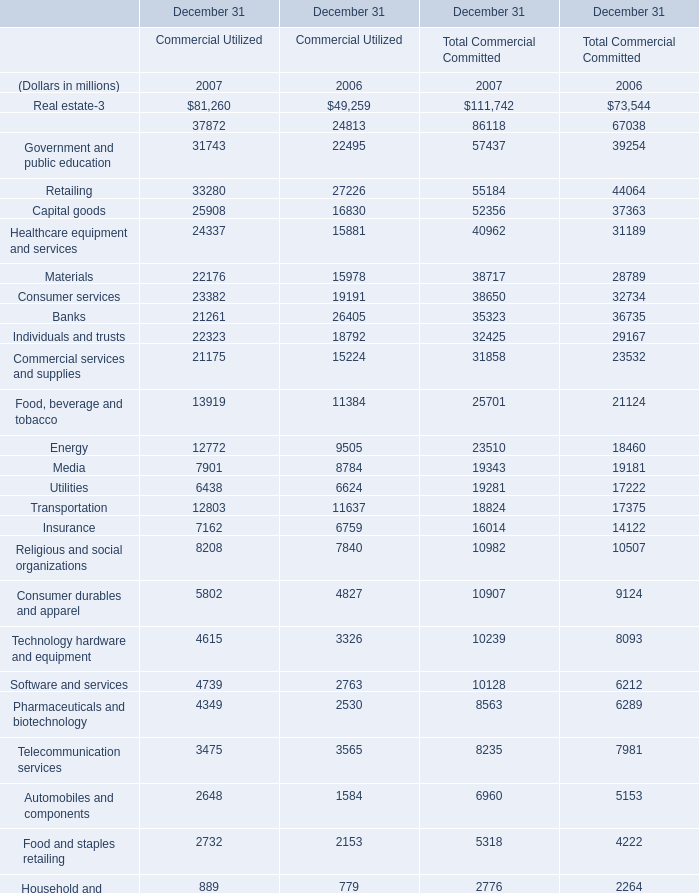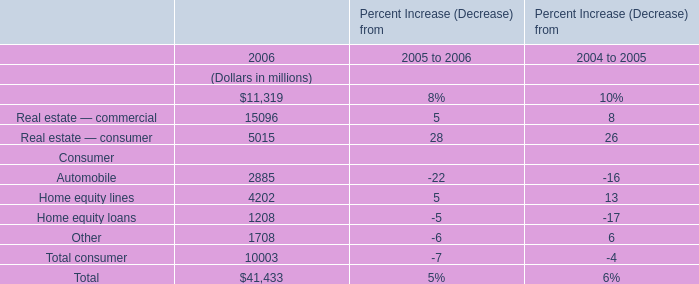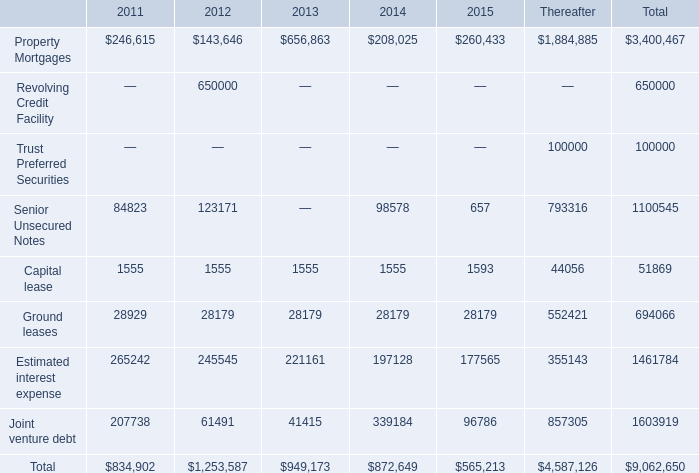What is the total amount of Estimated interest expense of 2012, Automobiles and components of December 31 Commercial Utilized 2007, and Property Mortgages of 2011 ? 
Computations: ((245545.0 + 2648.0) + 246615.0)
Answer: 494808.0. 